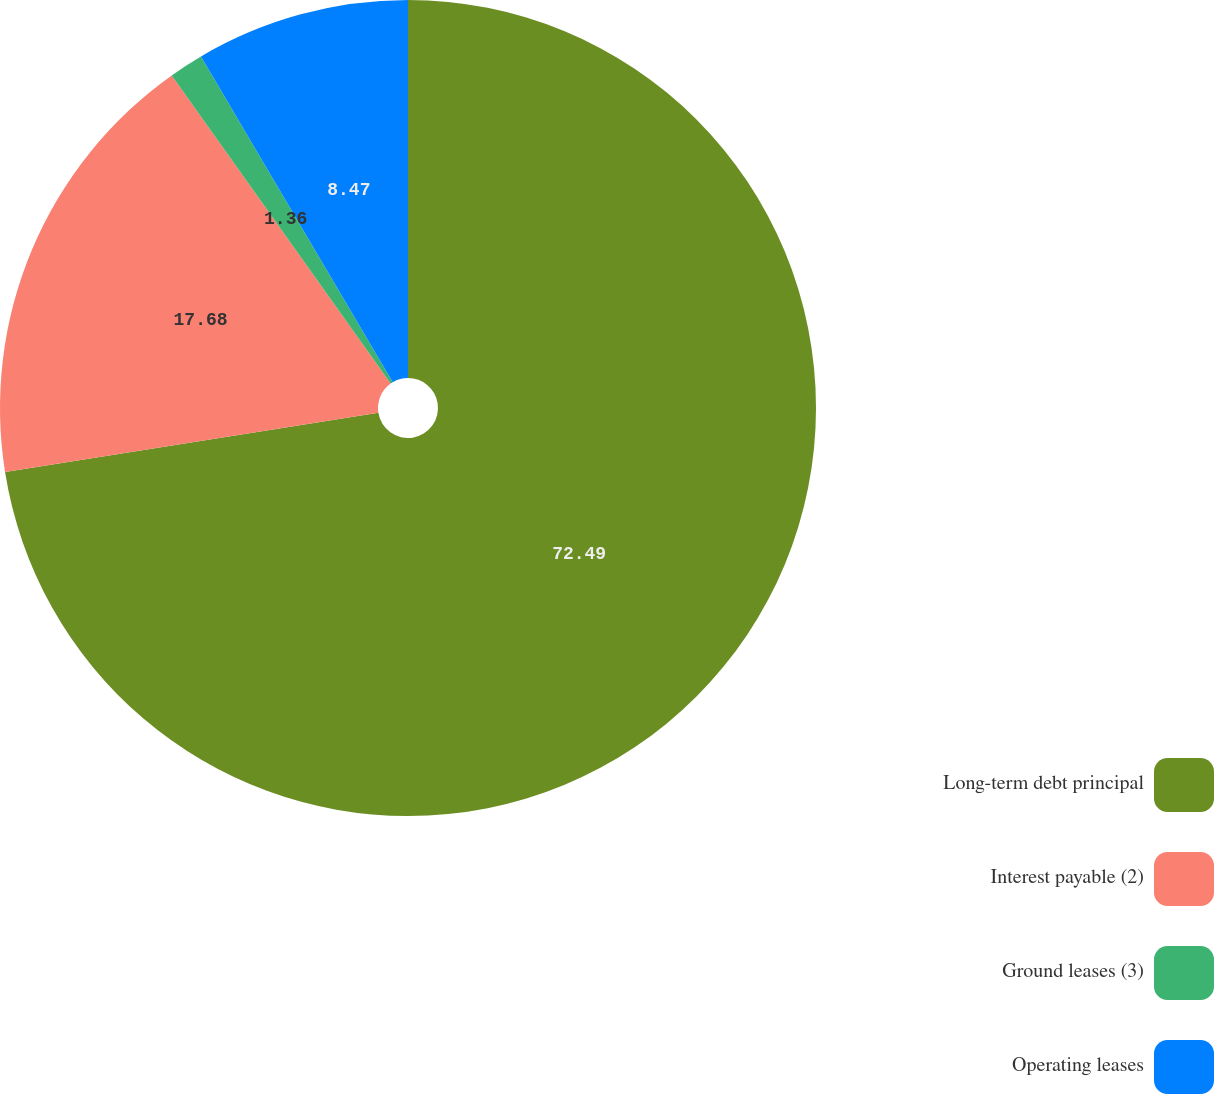Convert chart to OTSL. <chart><loc_0><loc_0><loc_500><loc_500><pie_chart><fcel>Long-term debt principal<fcel>Interest payable (2)<fcel>Ground leases (3)<fcel>Operating leases<nl><fcel>72.49%<fcel>17.68%<fcel>1.36%<fcel>8.47%<nl></chart> 